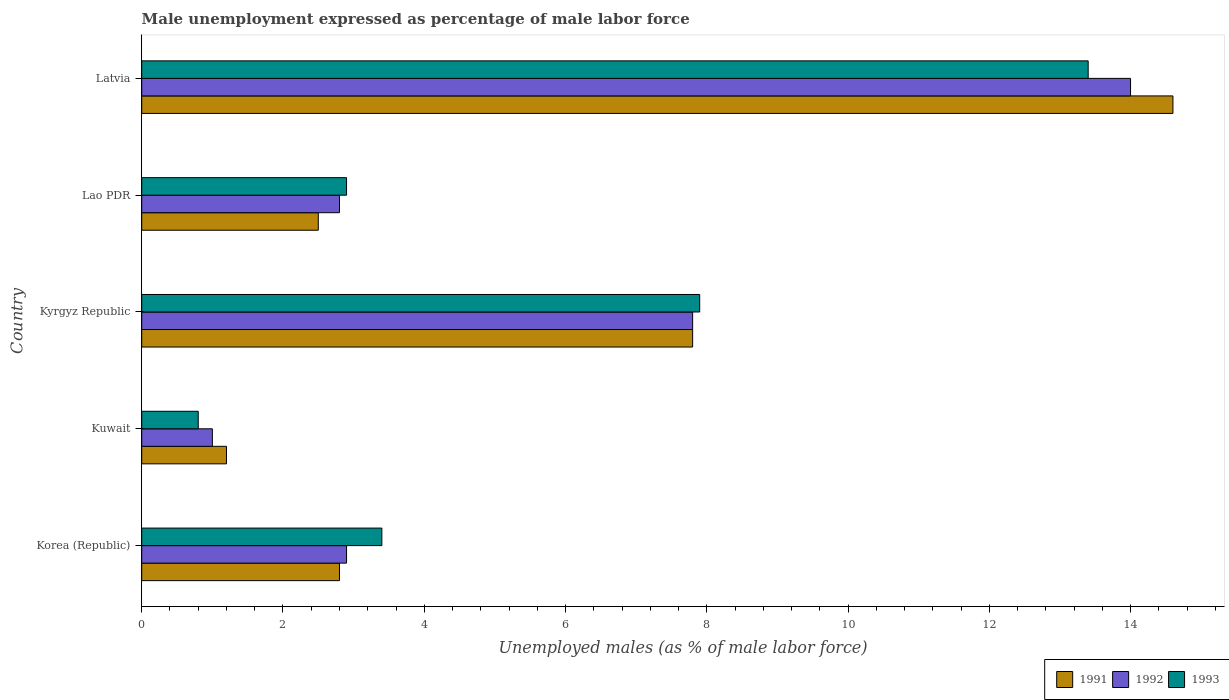How many different coloured bars are there?
Ensure brevity in your answer.  3. What is the label of the 2nd group of bars from the top?
Offer a very short reply. Lao PDR. What is the unemployment in males in in 1992 in Korea (Republic)?
Ensure brevity in your answer.  2.9. Across all countries, what is the maximum unemployment in males in in 1992?
Your answer should be compact. 14. In which country was the unemployment in males in in 1991 maximum?
Provide a succinct answer. Latvia. In which country was the unemployment in males in in 1991 minimum?
Provide a short and direct response. Kuwait. What is the total unemployment in males in in 1991 in the graph?
Offer a very short reply. 28.9. What is the difference between the unemployment in males in in 1992 in Kuwait and that in Kyrgyz Republic?
Offer a very short reply. -6.8. What is the difference between the unemployment in males in in 1992 in Lao PDR and the unemployment in males in in 1993 in Kuwait?
Provide a succinct answer. 2. What is the average unemployment in males in in 1991 per country?
Keep it short and to the point. 5.78. What is the ratio of the unemployment in males in in 1992 in Kuwait to that in Lao PDR?
Make the answer very short. 0.36. Is the difference between the unemployment in males in in 1992 in Korea (Republic) and Kuwait greater than the difference between the unemployment in males in in 1991 in Korea (Republic) and Kuwait?
Provide a succinct answer. Yes. What is the difference between the highest and the second highest unemployment in males in in 1992?
Provide a succinct answer. 6.2. In how many countries, is the unemployment in males in in 1993 greater than the average unemployment in males in in 1993 taken over all countries?
Make the answer very short. 2. Is the sum of the unemployment in males in in 1992 in Kuwait and Lao PDR greater than the maximum unemployment in males in in 1991 across all countries?
Offer a very short reply. No. How many bars are there?
Provide a short and direct response. 15. Are all the bars in the graph horizontal?
Offer a very short reply. Yes. How many countries are there in the graph?
Provide a succinct answer. 5. How many legend labels are there?
Ensure brevity in your answer.  3. What is the title of the graph?
Make the answer very short. Male unemployment expressed as percentage of male labor force. Does "1994" appear as one of the legend labels in the graph?
Keep it short and to the point. No. What is the label or title of the X-axis?
Your response must be concise. Unemployed males (as % of male labor force). What is the label or title of the Y-axis?
Provide a succinct answer. Country. What is the Unemployed males (as % of male labor force) in 1991 in Korea (Republic)?
Give a very brief answer. 2.8. What is the Unemployed males (as % of male labor force) in 1992 in Korea (Republic)?
Keep it short and to the point. 2.9. What is the Unemployed males (as % of male labor force) of 1993 in Korea (Republic)?
Offer a terse response. 3.4. What is the Unemployed males (as % of male labor force) in 1991 in Kuwait?
Give a very brief answer. 1.2. What is the Unemployed males (as % of male labor force) in 1992 in Kuwait?
Ensure brevity in your answer.  1. What is the Unemployed males (as % of male labor force) in 1993 in Kuwait?
Keep it short and to the point. 0.8. What is the Unemployed males (as % of male labor force) of 1991 in Kyrgyz Republic?
Offer a very short reply. 7.8. What is the Unemployed males (as % of male labor force) in 1992 in Kyrgyz Republic?
Your answer should be compact. 7.8. What is the Unemployed males (as % of male labor force) of 1993 in Kyrgyz Republic?
Ensure brevity in your answer.  7.9. What is the Unemployed males (as % of male labor force) of 1992 in Lao PDR?
Your answer should be very brief. 2.8. What is the Unemployed males (as % of male labor force) of 1993 in Lao PDR?
Ensure brevity in your answer.  2.9. What is the Unemployed males (as % of male labor force) in 1991 in Latvia?
Ensure brevity in your answer.  14.6. What is the Unemployed males (as % of male labor force) in 1992 in Latvia?
Your answer should be compact. 14. What is the Unemployed males (as % of male labor force) of 1993 in Latvia?
Provide a short and direct response. 13.4. Across all countries, what is the maximum Unemployed males (as % of male labor force) in 1991?
Offer a very short reply. 14.6. Across all countries, what is the maximum Unemployed males (as % of male labor force) of 1993?
Make the answer very short. 13.4. Across all countries, what is the minimum Unemployed males (as % of male labor force) in 1991?
Keep it short and to the point. 1.2. Across all countries, what is the minimum Unemployed males (as % of male labor force) in 1993?
Offer a terse response. 0.8. What is the total Unemployed males (as % of male labor force) of 1991 in the graph?
Make the answer very short. 28.9. What is the total Unemployed males (as % of male labor force) of 1992 in the graph?
Your answer should be compact. 28.5. What is the total Unemployed males (as % of male labor force) in 1993 in the graph?
Ensure brevity in your answer.  28.4. What is the difference between the Unemployed males (as % of male labor force) of 1993 in Korea (Republic) and that in Kuwait?
Offer a terse response. 2.6. What is the difference between the Unemployed males (as % of male labor force) of 1993 in Korea (Republic) and that in Kyrgyz Republic?
Give a very brief answer. -4.5. What is the difference between the Unemployed males (as % of male labor force) in 1993 in Korea (Republic) and that in Lao PDR?
Give a very brief answer. 0.5. What is the difference between the Unemployed males (as % of male labor force) in 1991 in Korea (Republic) and that in Latvia?
Provide a succinct answer. -11.8. What is the difference between the Unemployed males (as % of male labor force) in 1993 in Korea (Republic) and that in Latvia?
Your response must be concise. -10. What is the difference between the Unemployed males (as % of male labor force) in 1993 in Kuwait and that in Kyrgyz Republic?
Make the answer very short. -7.1. What is the difference between the Unemployed males (as % of male labor force) in 1992 in Kuwait and that in Lao PDR?
Keep it short and to the point. -1.8. What is the difference between the Unemployed males (as % of male labor force) of 1992 in Kuwait and that in Latvia?
Offer a very short reply. -13. What is the difference between the Unemployed males (as % of male labor force) in 1992 in Kyrgyz Republic and that in Lao PDR?
Provide a succinct answer. 5. What is the difference between the Unemployed males (as % of male labor force) of 1992 in Kyrgyz Republic and that in Latvia?
Ensure brevity in your answer.  -6.2. What is the difference between the Unemployed males (as % of male labor force) in 1991 in Lao PDR and that in Latvia?
Your answer should be very brief. -12.1. What is the difference between the Unemployed males (as % of male labor force) in 1992 in Lao PDR and that in Latvia?
Your answer should be very brief. -11.2. What is the difference between the Unemployed males (as % of male labor force) in 1991 in Korea (Republic) and the Unemployed males (as % of male labor force) in 1992 in Kyrgyz Republic?
Ensure brevity in your answer.  -5. What is the difference between the Unemployed males (as % of male labor force) in 1991 in Korea (Republic) and the Unemployed males (as % of male labor force) in 1993 in Kyrgyz Republic?
Give a very brief answer. -5.1. What is the difference between the Unemployed males (as % of male labor force) in 1992 in Korea (Republic) and the Unemployed males (as % of male labor force) in 1993 in Kyrgyz Republic?
Give a very brief answer. -5. What is the difference between the Unemployed males (as % of male labor force) in 1991 in Korea (Republic) and the Unemployed males (as % of male labor force) in 1992 in Lao PDR?
Keep it short and to the point. 0. What is the difference between the Unemployed males (as % of male labor force) of 1991 in Korea (Republic) and the Unemployed males (as % of male labor force) of 1993 in Lao PDR?
Your answer should be compact. -0.1. What is the difference between the Unemployed males (as % of male labor force) of 1992 in Korea (Republic) and the Unemployed males (as % of male labor force) of 1993 in Lao PDR?
Make the answer very short. 0. What is the difference between the Unemployed males (as % of male labor force) in 1991 in Korea (Republic) and the Unemployed males (as % of male labor force) in 1992 in Latvia?
Keep it short and to the point. -11.2. What is the difference between the Unemployed males (as % of male labor force) of 1992 in Korea (Republic) and the Unemployed males (as % of male labor force) of 1993 in Latvia?
Offer a terse response. -10.5. What is the difference between the Unemployed males (as % of male labor force) in 1991 in Kuwait and the Unemployed males (as % of male labor force) in 1992 in Kyrgyz Republic?
Provide a succinct answer. -6.6. What is the difference between the Unemployed males (as % of male labor force) of 1992 in Kuwait and the Unemployed males (as % of male labor force) of 1993 in Lao PDR?
Keep it short and to the point. -1.9. What is the difference between the Unemployed males (as % of male labor force) in 1991 in Kuwait and the Unemployed males (as % of male labor force) in 1992 in Latvia?
Offer a terse response. -12.8. What is the difference between the Unemployed males (as % of male labor force) in 1991 in Kyrgyz Republic and the Unemployed males (as % of male labor force) in 1992 in Lao PDR?
Your response must be concise. 5. What is the difference between the Unemployed males (as % of male labor force) of 1991 in Kyrgyz Republic and the Unemployed males (as % of male labor force) of 1993 in Lao PDR?
Provide a short and direct response. 4.9. What is the difference between the Unemployed males (as % of male labor force) of 1991 in Kyrgyz Republic and the Unemployed males (as % of male labor force) of 1992 in Latvia?
Provide a short and direct response. -6.2. What is the difference between the Unemployed males (as % of male labor force) of 1992 in Kyrgyz Republic and the Unemployed males (as % of male labor force) of 1993 in Latvia?
Keep it short and to the point. -5.6. What is the difference between the Unemployed males (as % of male labor force) of 1991 in Lao PDR and the Unemployed males (as % of male labor force) of 1992 in Latvia?
Provide a short and direct response. -11.5. What is the average Unemployed males (as % of male labor force) of 1991 per country?
Provide a succinct answer. 5.78. What is the average Unemployed males (as % of male labor force) in 1993 per country?
Give a very brief answer. 5.68. What is the difference between the Unemployed males (as % of male labor force) of 1991 and Unemployed males (as % of male labor force) of 1993 in Korea (Republic)?
Keep it short and to the point. -0.6. What is the difference between the Unemployed males (as % of male labor force) in 1991 and Unemployed males (as % of male labor force) in 1993 in Kyrgyz Republic?
Offer a very short reply. -0.1. What is the difference between the Unemployed males (as % of male labor force) in 1992 and Unemployed males (as % of male labor force) in 1993 in Kyrgyz Republic?
Your answer should be compact. -0.1. What is the ratio of the Unemployed males (as % of male labor force) in 1991 in Korea (Republic) to that in Kuwait?
Keep it short and to the point. 2.33. What is the ratio of the Unemployed males (as % of male labor force) of 1993 in Korea (Republic) to that in Kuwait?
Keep it short and to the point. 4.25. What is the ratio of the Unemployed males (as % of male labor force) of 1991 in Korea (Republic) to that in Kyrgyz Republic?
Offer a terse response. 0.36. What is the ratio of the Unemployed males (as % of male labor force) of 1992 in Korea (Republic) to that in Kyrgyz Republic?
Make the answer very short. 0.37. What is the ratio of the Unemployed males (as % of male labor force) of 1993 in Korea (Republic) to that in Kyrgyz Republic?
Give a very brief answer. 0.43. What is the ratio of the Unemployed males (as % of male labor force) in 1991 in Korea (Republic) to that in Lao PDR?
Give a very brief answer. 1.12. What is the ratio of the Unemployed males (as % of male labor force) in 1992 in Korea (Republic) to that in Lao PDR?
Your answer should be compact. 1.04. What is the ratio of the Unemployed males (as % of male labor force) in 1993 in Korea (Republic) to that in Lao PDR?
Ensure brevity in your answer.  1.17. What is the ratio of the Unemployed males (as % of male labor force) in 1991 in Korea (Republic) to that in Latvia?
Provide a succinct answer. 0.19. What is the ratio of the Unemployed males (as % of male labor force) of 1992 in Korea (Republic) to that in Latvia?
Make the answer very short. 0.21. What is the ratio of the Unemployed males (as % of male labor force) of 1993 in Korea (Republic) to that in Latvia?
Offer a very short reply. 0.25. What is the ratio of the Unemployed males (as % of male labor force) in 1991 in Kuwait to that in Kyrgyz Republic?
Your response must be concise. 0.15. What is the ratio of the Unemployed males (as % of male labor force) in 1992 in Kuwait to that in Kyrgyz Republic?
Your answer should be very brief. 0.13. What is the ratio of the Unemployed males (as % of male labor force) in 1993 in Kuwait to that in Kyrgyz Republic?
Provide a succinct answer. 0.1. What is the ratio of the Unemployed males (as % of male labor force) in 1991 in Kuwait to that in Lao PDR?
Offer a terse response. 0.48. What is the ratio of the Unemployed males (as % of male labor force) of 1992 in Kuwait to that in Lao PDR?
Offer a terse response. 0.36. What is the ratio of the Unemployed males (as % of male labor force) in 1993 in Kuwait to that in Lao PDR?
Provide a succinct answer. 0.28. What is the ratio of the Unemployed males (as % of male labor force) of 1991 in Kuwait to that in Latvia?
Make the answer very short. 0.08. What is the ratio of the Unemployed males (as % of male labor force) of 1992 in Kuwait to that in Latvia?
Offer a very short reply. 0.07. What is the ratio of the Unemployed males (as % of male labor force) in 1993 in Kuwait to that in Latvia?
Offer a terse response. 0.06. What is the ratio of the Unemployed males (as % of male labor force) of 1991 in Kyrgyz Republic to that in Lao PDR?
Make the answer very short. 3.12. What is the ratio of the Unemployed males (as % of male labor force) of 1992 in Kyrgyz Republic to that in Lao PDR?
Provide a succinct answer. 2.79. What is the ratio of the Unemployed males (as % of male labor force) of 1993 in Kyrgyz Republic to that in Lao PDR?
Your answer should be compact. 2.72. What is the ratio of the Unemployed males (as % of male labor force) in 1991 in Kyrgyz Republic to that in Latvia?
Make the answer very short. 0.53. What is the ratio of the Unemployed males (as % of male labor force) of 1992 in Kyrgyz Republic to that in Latvia?
Offer a very short reply. 0.56. What is the ratio of the Unemployed males (as % of male labor force) of 1993 in Kyrgyz Republic to that in Latvia?
Offer a very short reply. 0.59. What is the ratio of the Unemployed males (as % of male labor force) of 1991 in Lao PDR to that in Latvia?
Your answer should be very brief. 0.17. What is the ratio of the Unemployed males (as % of male labor force) of 1993 in Lao PDR to that in Latvia?
Keep it short and to the point. 0.22. What is the difference between the highest and the second highest Unemployed males (as % of male labor force) in 1991?
Provide a short and direct response. 6.8. What is the difference between the highest and the second highest Unemployed males (as % of male labor force) of 1992?
Keep it short and to the point. 6.2. What is the difference between the highest and the second highest Unemployed males (as % of male labor force) of 1993?
Your response must be concise. 5.5. What is the difference between the highest and the lowest Unemployed males (as % of male labor force) of 1992?
Offer a very short reply. 13. 